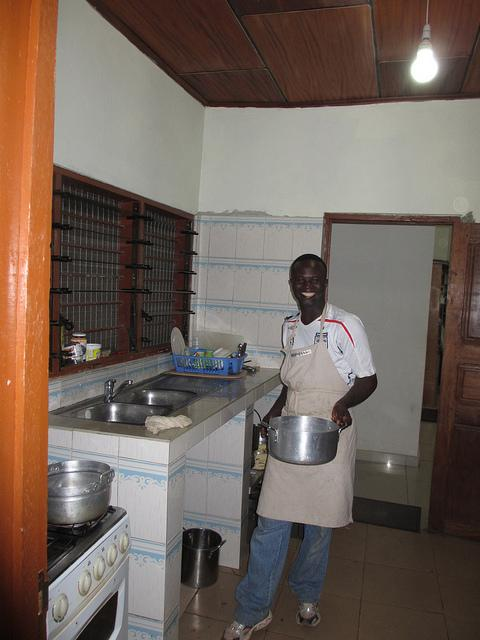This man is in a similar profession to what character?

Choices:
A) homer simpson
B) pikachu
C) chef boyardee
D) garfield chef boyardee 